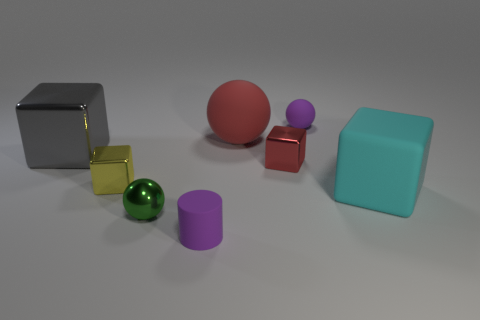What color is the rubber object that is right of the small red metal object and behind the big metal cube?
Provide a succinct answer. Purple. What color is the small metal ball?
Offer a terse response. Green. Do the small yellow thing and the purple object behind the big cyan matte thing have the same material?
Offer a very short reply. No. The green thing that is made of the same material as the yellow cube is what shape?
Provide a short and direct response. Sphere. What is the color of the cylinder that is the same size as the red block?
Your answer should be compact. Purple. Do the cube in front of the yellow cube and the tiny red cube have the same size?
Give a very brief answer. No. Does the metal sphere have the same color as the rubber cylinder?
Offer a very short reply. No. What number of red metal cubes are there?
Ensure brevity in your answer.  1. How many cubes are either purple matte objects or large gray things?
Provide a short and direct response. 1. There is a object that is in front of the metal ball; what number of small metal cubes are to the left of it?
Provide a short and direct response. 1. 